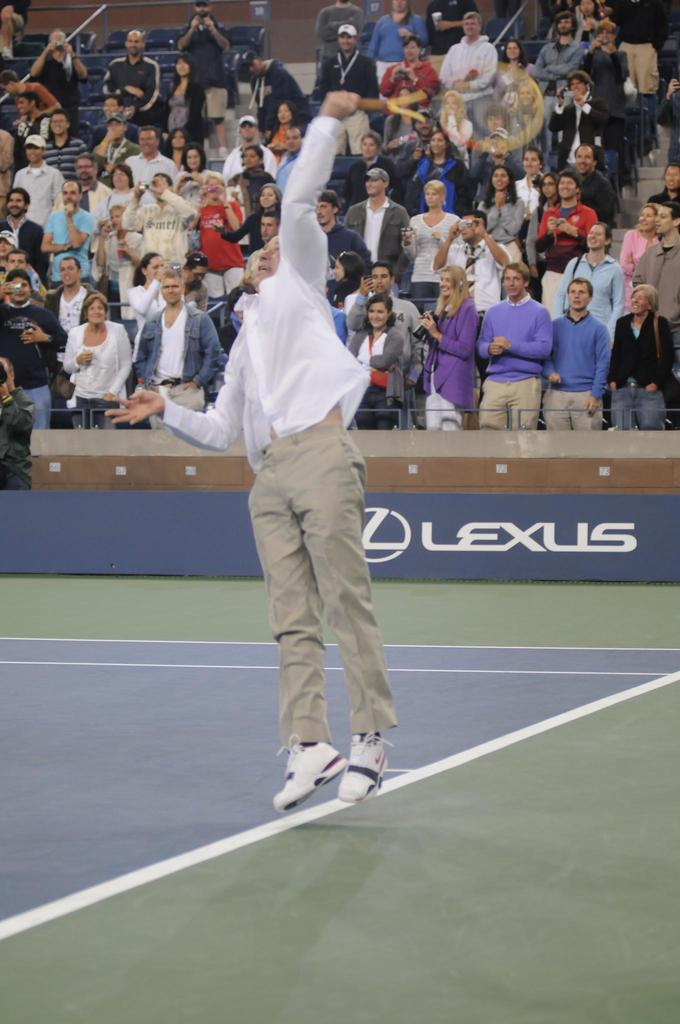What is the man in the image wearing? The man in the image is wearing a white shirt. What is the man holding in the image? The man is holding a racket. What action is the man performing in the image? The man is jumping. Who else is present in the image besides the man with the racket? There are people in the image who appear to be an audience. How are the audience members positioned in the image? The audience members are standing. What type of rule is being enforced by the plate in the image? There is no plate present in the image, and therefore no rule can be enforced by it. 